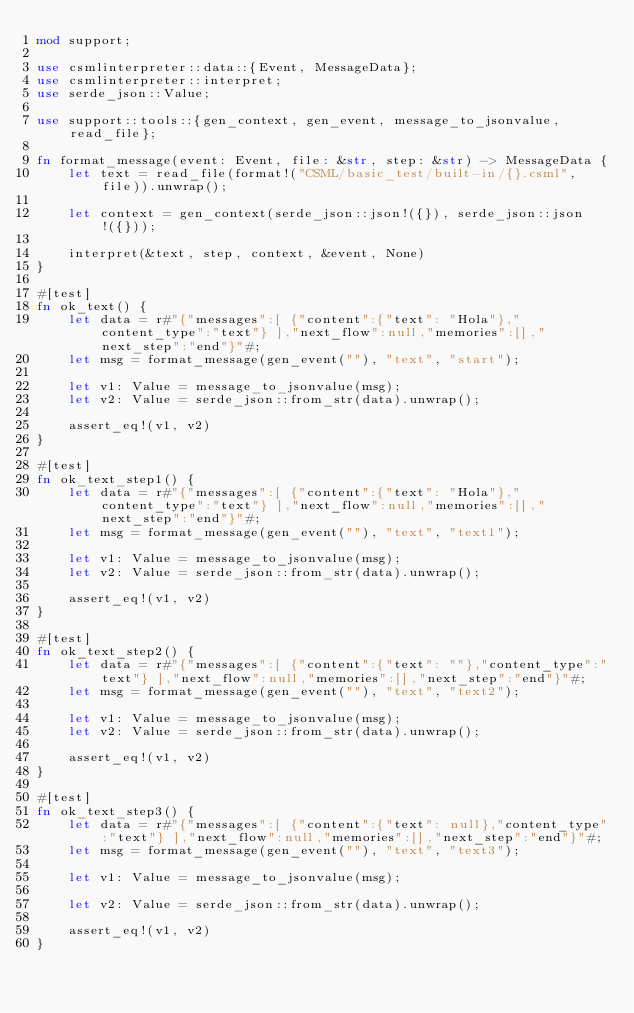Convert code to text. <code><loc_0><loc_0><loc_500><loc_500><_Rust_>mod support;

use csmlinterpreter::data::{Event, MessageData};
use csmlinterpreter::interpret;
use serde_json::Value;

use support::tools::{gen_context, gen_event, message_to_jsonvalue, read_file};

fn format_message(event: Event, file: &str, step: &str) -> MessageData {
    let text = read_file(format!("CSML/basic_test/built-in/{}.csml", file)).unwrap();

    let context = gen_context(serde_json::json!({}), serde_json::json!({}));

    interpret(&text, step, context, &event, None)
}

#[test]
fn ok_text() {
    let data = r#"{"messages":[ {"content":{"text": "Hola"},"content_type":"text"} ],"next_flow":null,"memories":[],"next_step":"end"}"#;
    let msg = format_message(gen_event(""), "text", "start");

    let v1: Value = message_to_jsonvalue(msg);
    let v2: Value = serde_json::from_str(data).unwrap();

    assert_eq!(v1, v2)
}

#[test]
fn ok_text_step1() {
    let data = r#"{"messages":[ {"content":{"text": "Hola"},"content_type":"text"} ],"next_flow":null,"memories":[],"next_step":"end"}"#;
    let msg = format_message(gen_event(""), "text", "text1");

    let v1: Value = message_to_jsonvalue(msg);
    let v2: Value = serde_json::from_str(data).unwrap();

    assert_eq!(v1, v2)
}

#[test]
fn ok_text_step2() {
    let data = r#"{"messages":[ {"content":{"text": ""},"content_type":"text"} ],"next_flow":null,"memories":[],"next_step":"end"}"#;
    let msg = format_message(gen_event(""), "text", "text2");

    let v1: Value = message_to_jsonvalue(msg);
    let v2: Value = serde_json::from_str(data).unwrap();

    assert_eq!(v1, v2)
}

#[test]
fn ok_text_step3() {
    let data = r#"{"messages":[ {"content":{"text": null},"content_type":"text"} ],"next_flow":null,"memories":[],"next_step":"end"}"#;
    let msg = format_message(gen_event(""), "text", "text3");

    let v1: Value = message_to_jsonvalue(msg);

    let v2: Value = serde_json::from_str(data).unwrap();

    assert_eq!(v1, v2)
}
</code> 